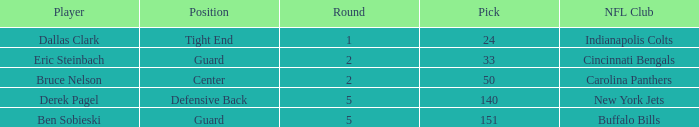During which round was a Hawkeyes player selected for the defensive back position? 5.0. 